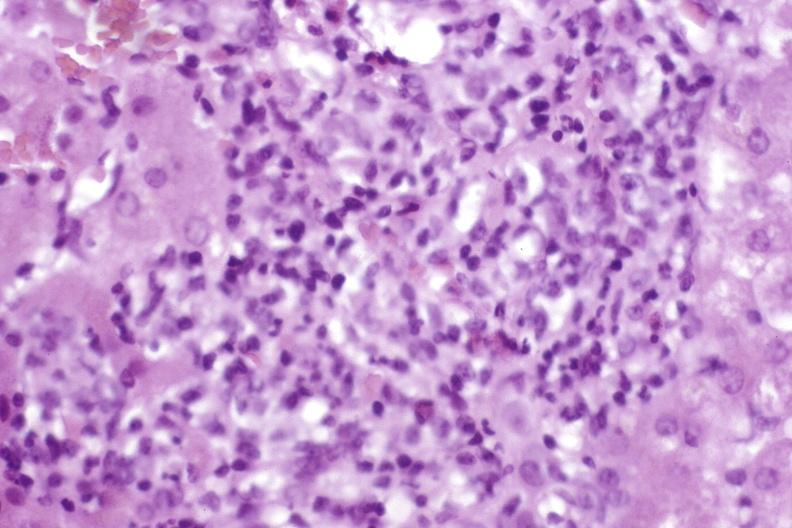what is present?
Answer the question using a single word or phrase. Hepatobiliary 